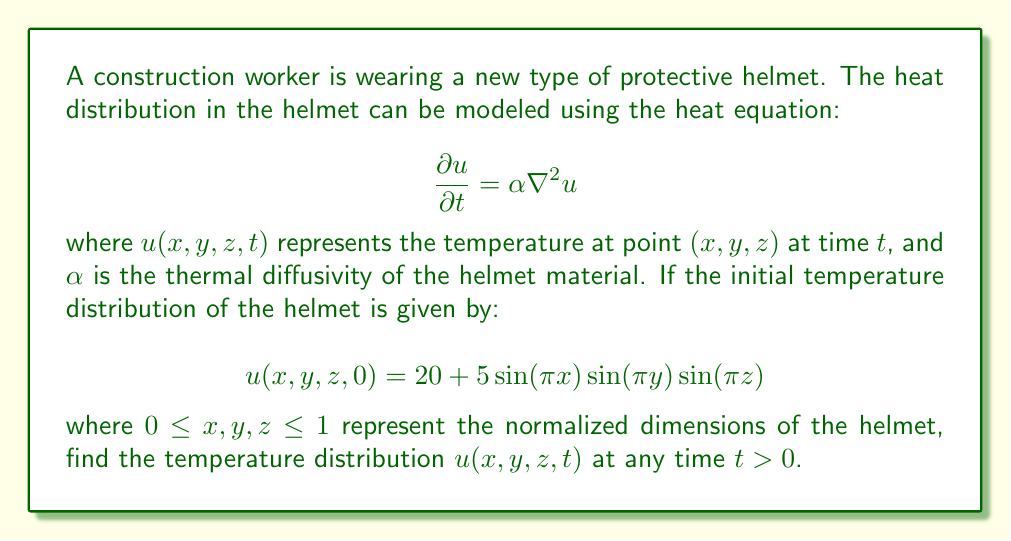What is the answer to this math problem? To solve this partial differential equation, we can use the method of separation of variables. Let's assume the solution has the form:

$$u(x,y,z,t) = X(x)Y(y)Z(z)T(t)$$

Substituting this into the heat equation and dividing by $XYZ$, we get:

$$\frac{1}{X}\frac{d^2X}{dx^2} + \frac{1}{Y}\frac{d^2Y}{dy^2} + \frac{1}{Z}\frac{d^2Z}{dz^2} = \frac{1}{\alpha T}\frac{dT}{dt}$$

This equation must be satisfied for all $x$, $y$, $z$, and $t$, so each term must be equal to a constant. Let's call this constant $-k^2$. This gives us four ordinary differential equations:

1. $\frac{d^2X}{dx^2} + k^2X = 0$
2. $\frac{d^2Y}{dy^2} + k^2Y = 0$
3. $\frac{d^2Z}{dz^2} + k^2Z = 0$
4. $\frac{dT}{dt} + \alpha k^2T = 0$

The solutions to these equations, considering the boundary conditions (temperature is finite at the boundaries), are:

1. $X(x) = A\sin(nx\pi)$
2. $Y(y) = B\sin(my\pi)$
3. $Z(z) = C\sin(lz\pi)$
4. $T(t) = De^{-\alpha(n^2+m^2+l^2)\pi^2t}$

where $n$, $m$, and $l$ are positive integers.

The general solution is a linear combination of all possible solutions:

$$u(x,y,z,t) = \sum_{n=1}^{\infty}\sum_{m=1}^{\infty}\sum_{l=1}^{\infty} A_{nml}\sin(nx\pi)\sin(my\pi)\sin(lz\pi)e^{-\alpha(n^2+m^2+l^2)\pi^2t}$$

To find $A_{nml}$, we use the initial condition:

$$u(x,y,z,0) = 20 + 5\sin(\pi x)\sin(\pi y)\sin(\pi z)$$

This matches our general solution when $n=m=l=1$ and all other terms are zero. Therefore:

$$A_{111} = 5$$
$$A_{000} = 20$$ (constant term)
All other $A_{nml} = 0$

Thus, the final solution is:

$$u(x,y,z,t) = 20 + 5\sin(\pi x)\sin(\pi y)\sin(\pi z)e^{-3\alpha\pi^2t}$$
Answer: $$u(x,y,z,t) = 20 + 5\sin(\pi x)\sin(\pi y)\sin(\pi z)e^{-3\alpha\pi^2t}$$ 